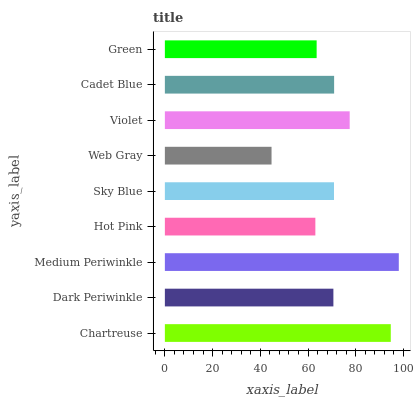Is Web Gray the minimum?
Answer yes or no. Yes. Is Medium Periwinkle the maximum?
Answer yes or no. Yes. Is Dark Periwinkle the minimum?
Answer yes or no. No. Is Dark Periwinkle the maximum?
Answer yes or no. No. Is Chartreuse greater than Dark Periwinkle?
Answer yes or no. Yes. Is Dark Periwinkle less than Chartreuse?
Answer yes or no. Yes. Is Dark Periwinkle greater than Chartreuse?
Answer yes or no. No. Is Chartreuse less than Dark Periwinkle?
Answer yes or no. No. Is Sky Blue the high median?
Answer yes or no. Yes. Is Sky Blue the low median?
Answer yes or no. Yes. Is Violet the high median?
Answer yes or no. No. Is Hot Pink the low median?
Answer yes or no. No. 